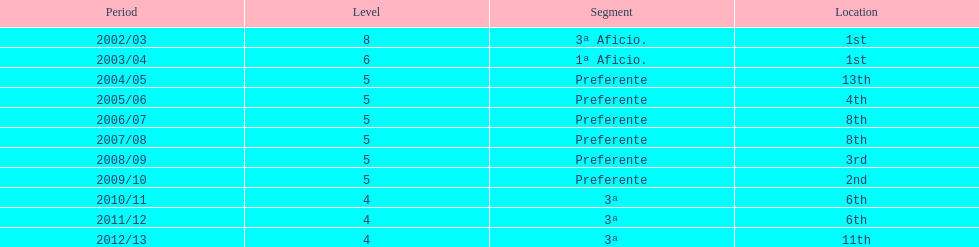In what year did the team achieve the same place as 2010/11? 2011/12. 